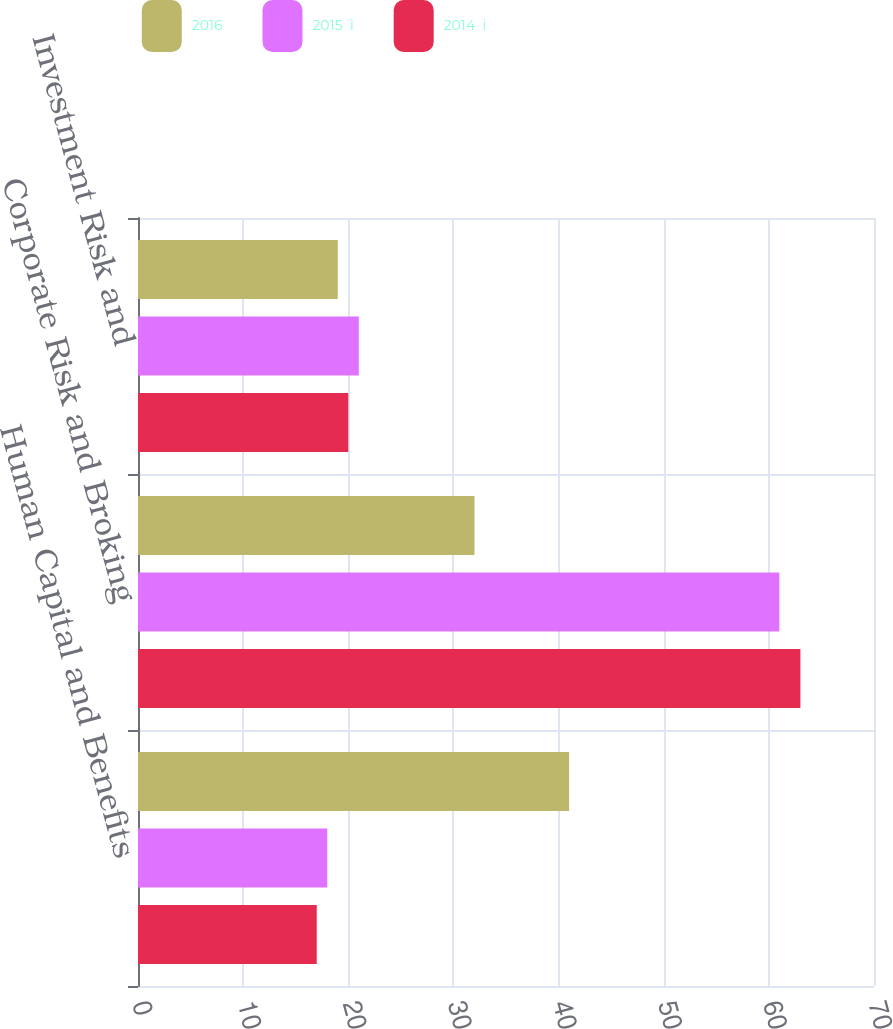Convert chart to OTSL. <chart><loc_0><loc_0><loc_500><loc_500><stacked_bar_chart><ecel><fcel>Human Capital and Benefits<fcel>Corporate Risk and Broking<fcel>Investment Risk and<nl><fcel>2016<fcel>41<fcel>32<fcel>19<nl><fcel>2015  i<fcel>18<fcel>61<fcel>21<nl><fcel>2014  i<fcel>17<fcel>63<fcel>20<nl></chart> 